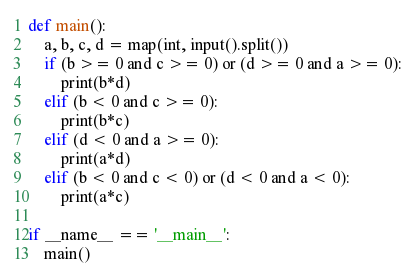Convert code to text. <code><loc_0><loc_0><loc_500><loc_500><_Python_>def main():
    a, b, c, d = map(int, input().split())
    if (b >= 0 and c >= 0) or (d >= 0 and a >= 0):
        print(b*d)
    elif (b < 0 and c >= 0):
        print(b*c)
    elif (d < 0 and a >= 0):
        print(a*d)
    elif (b < 0 and c < 0) or (d < 0 and a < 0):
        print(a*c)

if __name__ == '__main__':
    main()</code> 